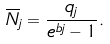<formula> <loc_0><loc_0><loc_500><loc_500>\overline { N } _ { j } = \frac { q _ { j } } { e ^ { b j } - 1 } .</formula> 